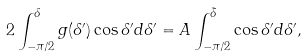<formula> <loc_0><loc_0><loc_500><loc_500>2 \int _ { - \pi / 2 } ^ { \delta } g ( \delta ^ { \prime } ) \cos \delta ^ { \prime } d \delta ^ { \prime } = A \int _ { - \pi / 2 } ^ { \tilde { \delta } } \cos \delta ^ { \prime } d \delta ^ { \prime } ,</formula> 